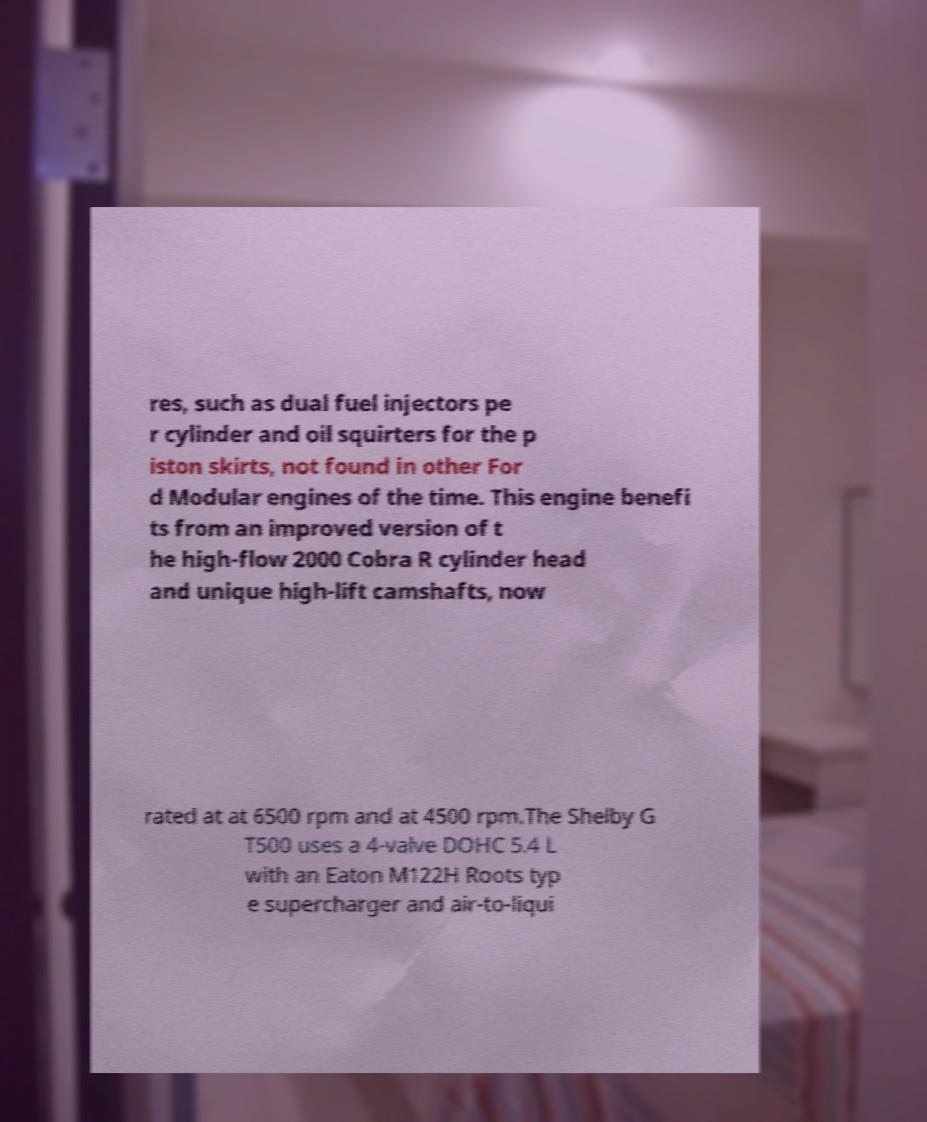Please identify and transcribe the text found in this image. res, such as dual fuel injectors pe r cylinder and oil squirters for the p iston skirts, not found in other For d Modular engines of the time. This engine benefi ts from an improved version of t he high-flow 2000 Cobra R cylinder head and unique high-lift camshafts, now rated at at 6500 rpm and at 4500 rpm.The Shelby G T500 uses a 4-valve DOHC 5.4 L with an Eaton M122H Roots typ e supercharger and air-to-liqui 